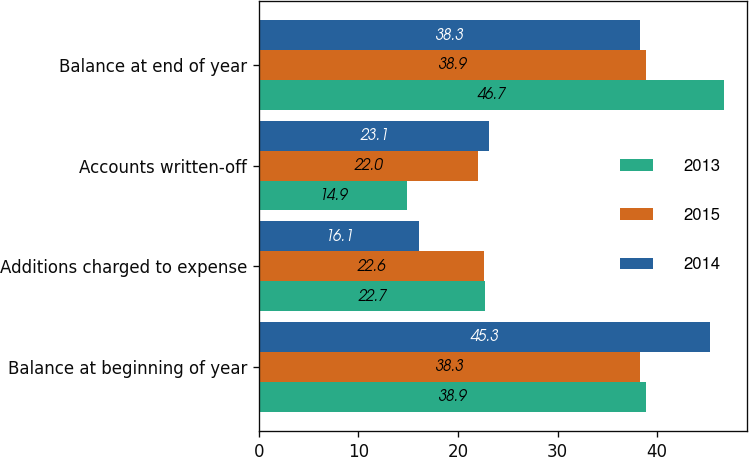<chart> <loc_0><loc_0><loc_500><loc_500><stacked_bar_chart><ecel><fcel>Balance at beginning of year<fcel>Additions charged to expense<fcel>Accounts written-off<fcel>Balance at end of year<nl><fcel>2013<fcel>38.9<fcel>22.7<fcel>14.9<fcel>46.7<nl><fcel>2015<fcel>38.3<fcel>22.6<fcel>22<fcel>38.9<nl><fcel>2014<fcel>45.3<fcel>16.1<fcel>23.1<fcel>38.3<nl></chart> 